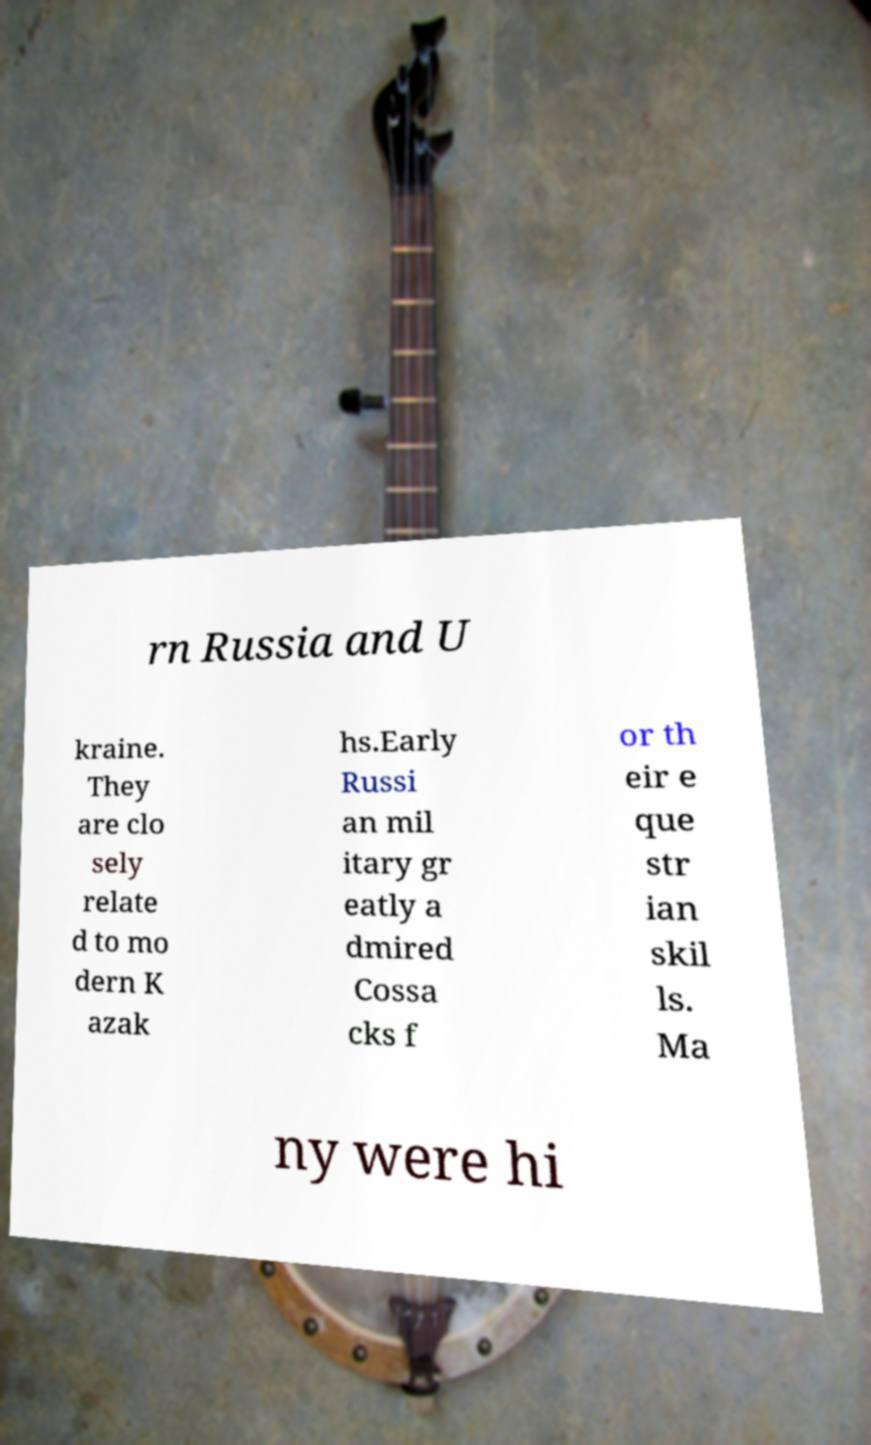What messages or text are displayed in this image? I need them in a readable, typed format. rn Russia and U kraine. They are clo sely relate d to mo dern K azak hs.Early Russi an mil itary gr eatly a dmired Cossa cks f or th eir e que str ian skil ls. Ma ny were hi 